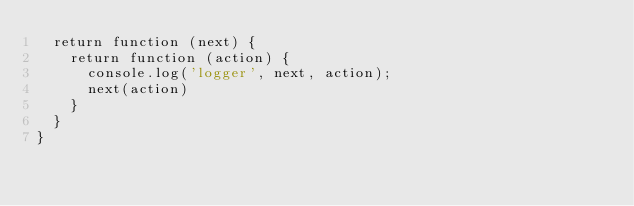<code> <loc_0><loc_0><loc_500><loc_500><_JavaScript_>  return function (next) {
    return function (action) {
      console.log('logger', next, action);
      next(action)
    }
  }
}</code> 